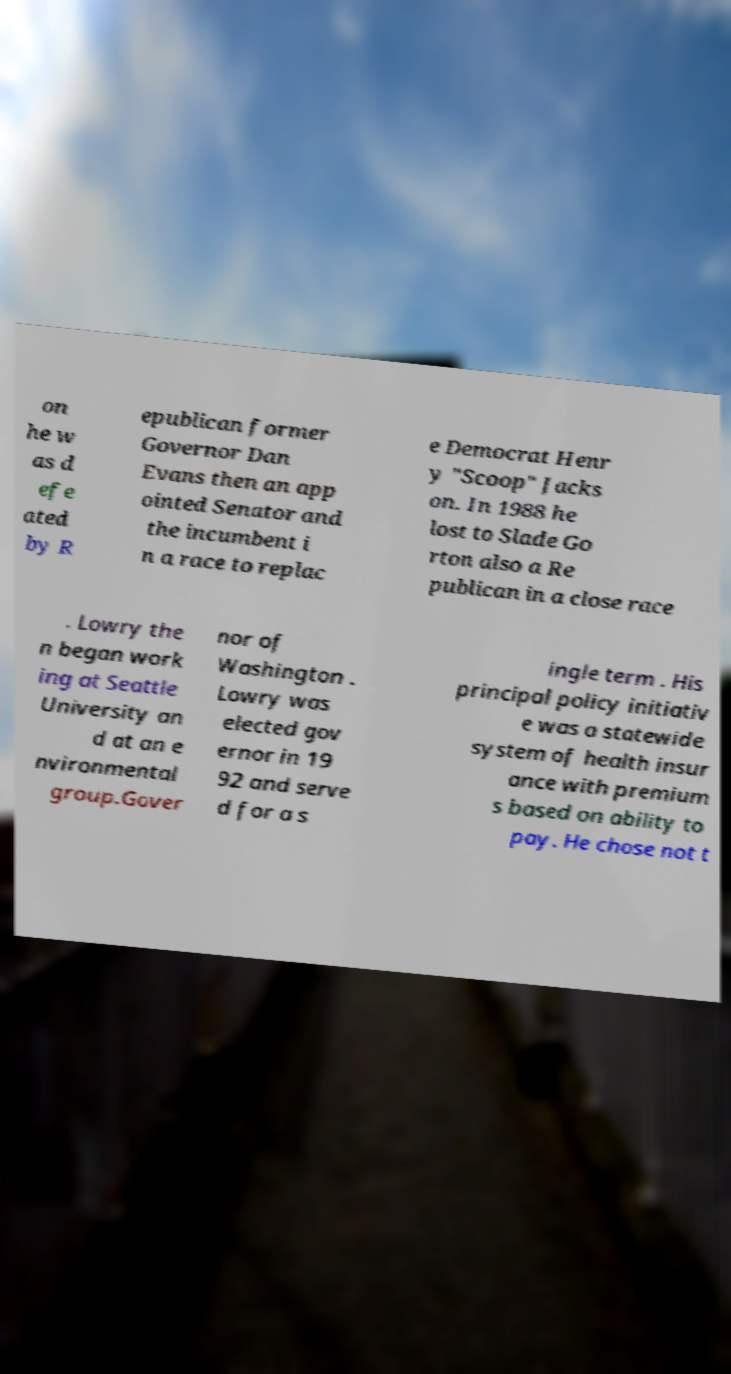What messages or text are displayed in this image? I need them in a readable, typed format. on he w as d efe ated by R epublican former Governor Dan Evans then an app ointed Senator and the incumbent i n a race to replac e Democrat Henr y "Scoop" Jacks on. In 1988 he lost to Slade Go rton also a Re publican in a close race . Lowry the n began work ing at Seattle University an d at an e nvironmental group.Gover nor of Washington . Lowry was elected gov ernor in 19 92 and serve d for a s ingle term . His principal policy initiativ e was a statewide system of health insur ance with premium s based on ability to pay. He chose not t 